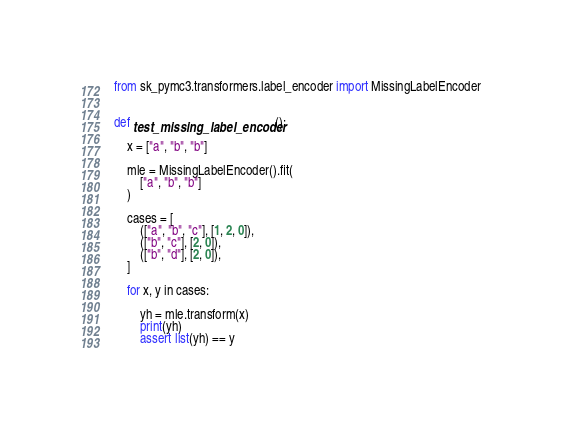<code> <loc_0><loc_0><loc_500><loc_500><_Python_>from sk_pymc3.transformers.label_encoder import MissingLabelEncoder


def test_missing_label_encoder():

    x = ["a", "b", "b"]

    mle = MissingLabelEncoder().fit(
        ["a", "b", "b"]
    )

    cases = [
        (["a", "b", "c"], [1, 2, 0]),
        (["b", "c"], [2, 0]),
        (["b", "d"], [2, 0]),
    ]

    for x, y in cases:

        yh = mle.transform(x)
        print(yh)
        assert list(yh) == y</code> 